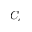Convert formula to latex. <formula><loc_0><loc_0><loc_500><loc_500>C _ { c }</formula> 